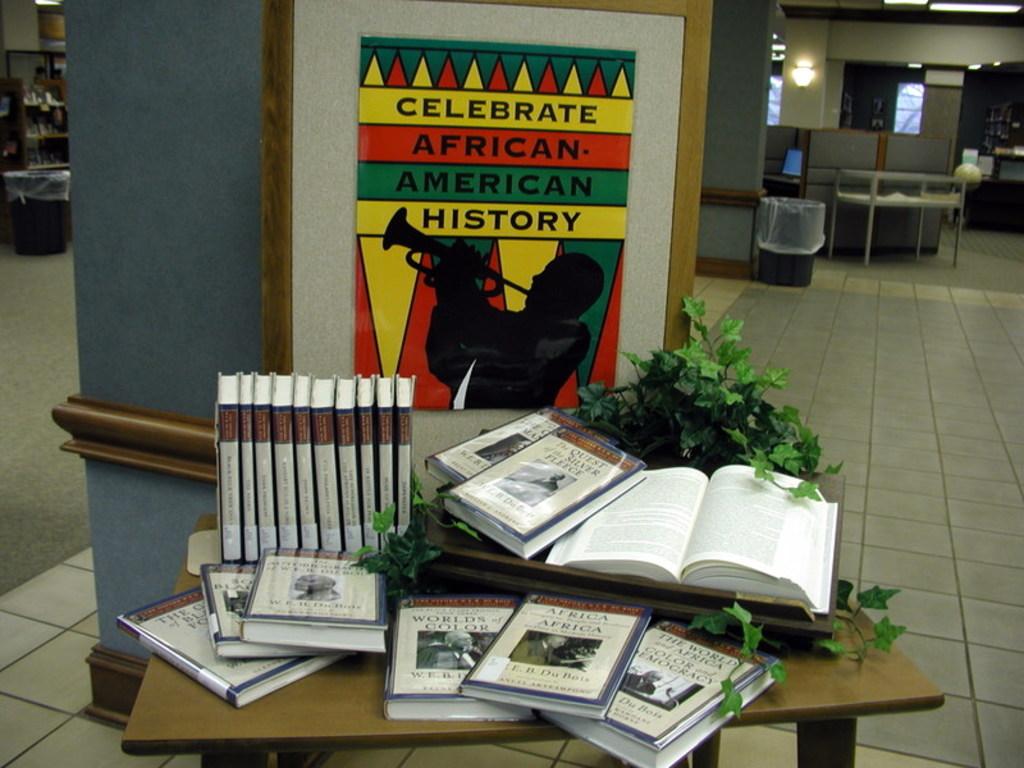Does it want you to celebrate african american history?
Provide a short and direct response. Yes. 